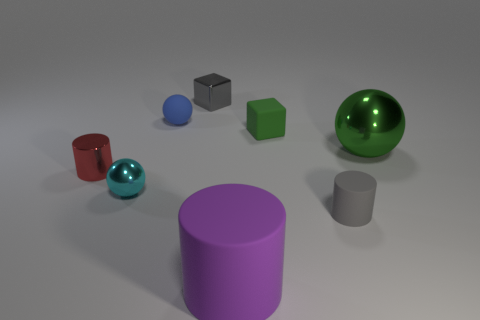What material is the other small object that is the same shape as the tiny gray metallic object?
Offer a very short reply. Rubber. How many shiny objects are either tiny gray blocks or big spheres?
Ensure brevity in your answer.  2. Are the cube that is in front of the gray shiny thing and the small cylinder that is left of the big purple thing made of the same material?
Make the answer very short. No. Are there any large blue spheres?
Make the answer very short. No. Does the gray thing behind the large green metallic ball have the same shape as the small rubber object in front of the rubber cube?
Make the answer very short. No. Are there any tiny yellow cylinders that have the same material as the big sphere?
Your answer should be compact. No. Is the material of the gray thing behind the red object the same as the green block?
Provide a succinct answer. No. Are there more tiny gray metallic objects that are behind the big purple cylinder than gray metallic cubes behind the gray block?
Your answer should be very brief. Yes. What color is the other object that is the same size as the purple thing?
Make the answer very short. Green. Is there a big rubber cylinder of the same color as the rubber cube?
Your answer should be compact. No. 